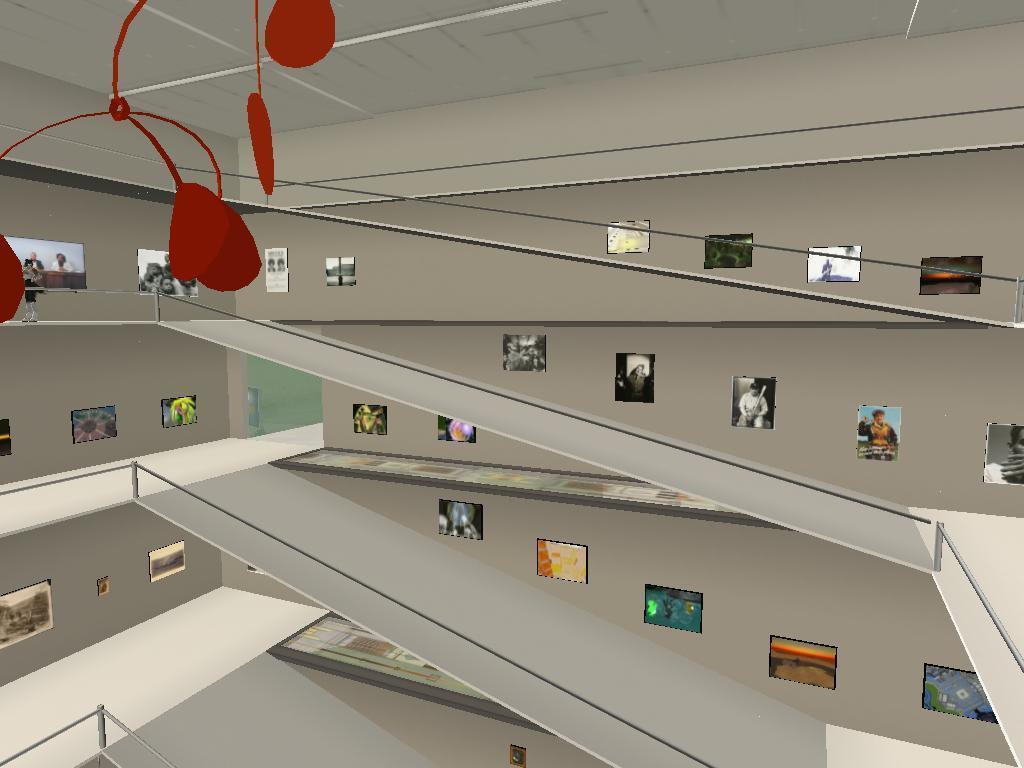Please provide a concise description of this image. This is an animated picture. I can see the inside view of a building. I can see frames attached to the walls and there are some other objects. 